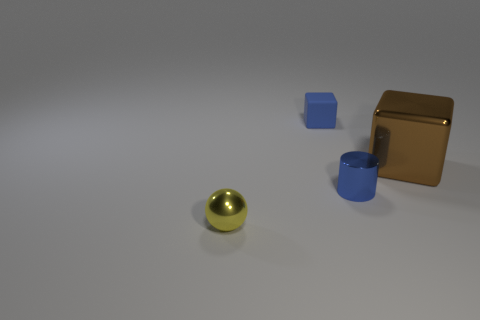What material is the blue cube that is the same size as the yellow metallic thing?
Offer a terse response. Rubber. There is a blue object that is behind the small cylinder; what size is it?
Keep it short and to the point. Small. Do the thing that is in front of the small blue metallic object and the object that is to the right of the small cylinder have the same size?
Provide a succinct answer. No. What number of tiny blue objects have the same material as the yellow object?
Provide a succinct answer. 1. What color is the large shiny cube?
Provide a succinct answer. Brown. There is a big thing; are there any tiny metallic cylinders to the right of it?
Provide a succinct answer. No. Is the matte object the same color as the cylinder?
Keep it short and to the point. Yes. What number of tiny cylinders are the same color as the small ball?
Keep it short and to the point. 0. There is a blue thing that is in front of the block that is in front of the tiny block; what size is it?
Provide a succinct answer. Small. The yellow metal object has what shape?
Offer a terse response. Sphere. 